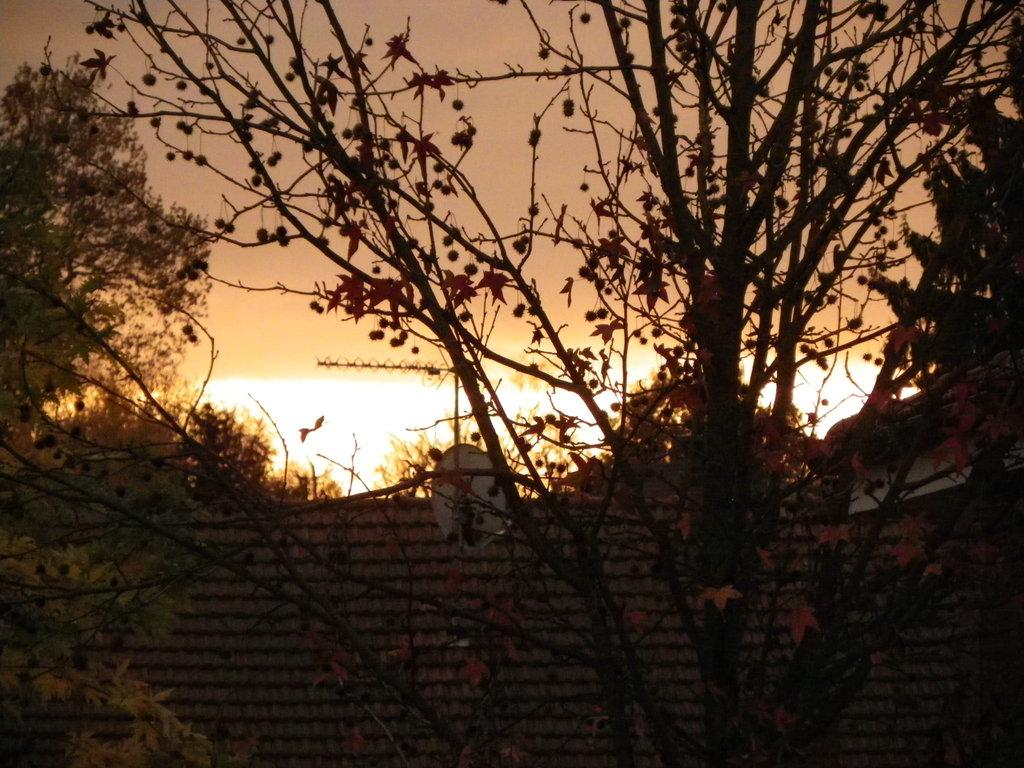What type of vegetation can be seen in the image? There are trees in the image. What structure is visible in the image? There is a roof in the image. What is visible in the background of the image? The sky is visible in the background of the image. How many giants can be seen in the image? There are no giants present in the image. What type of land is visible in the image? The image does not show any specific type of land; it only features trees, a roof, and the sky. 